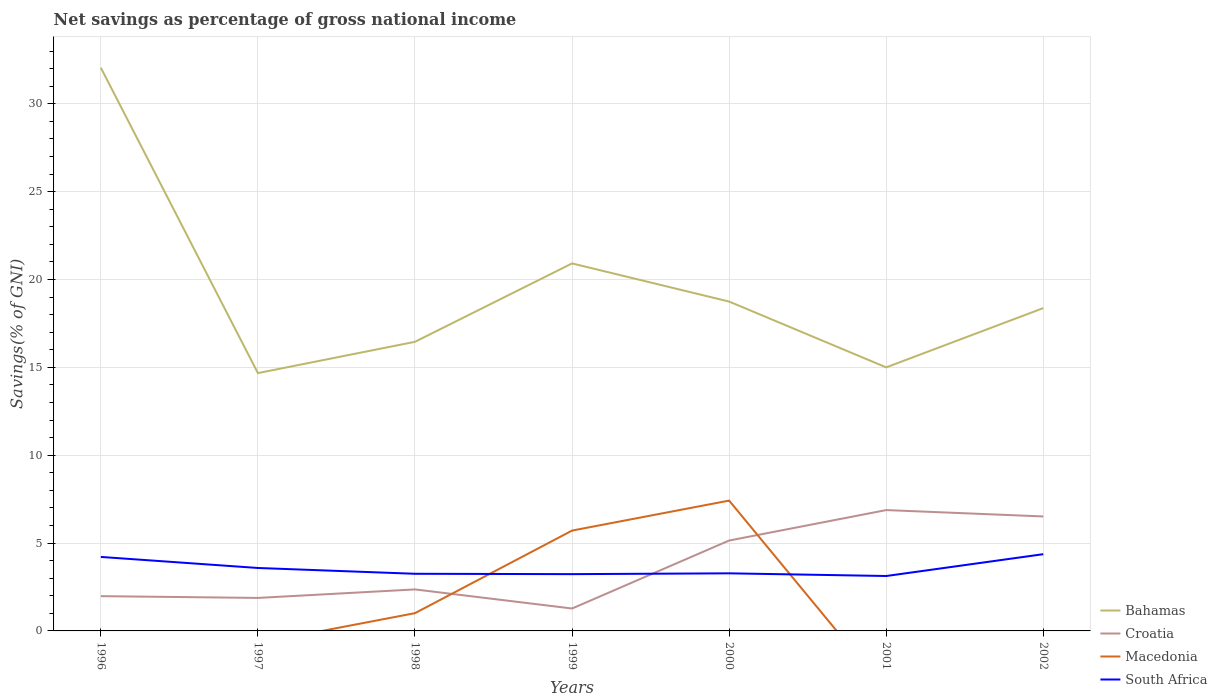Is the number of lines equal to the number of legend labels?
Keep it short and to the point. No. Across all years, what is the maximum total savings in Bahamas?
Give a very brief answer. 14.67. What is the total total savings in South Africa in the graph?
Ensure brevity in your answer.  0.02. What is the difference between the highest and the second highest total savings in Macedonia?
Your answer should be very brief. 7.42. What is the difference between the highest and the lowest total savings in Croatia?
Provide a short and direct response. 3. How are the legend labels stacked?
Your answer should be very brief. Vertical. What is the title of the graph?
Your answer should be very brief. Net savings as percentage of gross national income. What is the label or title of the X-axis?
Give a very brief answer. Years. What is the label or title of the Y-axis?
Your response must be concise. Savings(% of GNI). What is the Savings(% of GNI) in Bahamas in 1996?
Give a very brief answer. 32.05. What is the Savings(% of GNI) in Croatia in 1996?
Your response must be concise. 1.98. What is the Savings(% of GNI) of South Africa in 1996?
Your answer should be very brief. 4.21. What is the Savings(% of GNI) of Bahamas in 1997?
Make the answer very short. 14.67. What is the Savings(% of GNI) of Croatia in 1997?
Your response must be concise. 1.88. What is the Savings(% of GNI) in South Africa in 1997?
Your answer should be compact. 3.58. What is the Savings(% of GNI) in Bahamas in 1998?
Your answer should be compact. 16.45. What is the Savings(% of GNI) of Croatia in 1998?
Your response must be concise. 2.36. What is the Savings(% of GNI) in Macedonia in 1998?
Provide a succinct answer. 1.01. What is the Savings(% of GNI) of South Africa in 1998?
Provide a short and direct response. 3.25. What is the Savings(% of GNI) in Bahamas in 1999?
Your answer should be very brief. 20.91. What is the Savings(% of GNI) in Croatia in 1999?
Your answer should be very brief. 1.28. What is the Savings(% of GNI) of Macedonia in 1999?
Provide a succinct answer. 5.71. What is the Savings(% of GNI) of South Africa in 1999?
Provide a succinct answer. 3.23. What is the Savings(% of GNI) of Bahamas in 2000?
Your response must be concise. 18.74. What is the Savings(% of GNI) in Croatia in 2000?
Your response must be concise. 5.14. What is the Savings(% of GNI) of Macedonia in 2000?
Ensure brevity in your answer.  7.42. What is the Savings(% of GNI) of South Africa in 2000?
Your response must be concise. 3.28. What is the Savings(% of GNI) in Bahamas in 2001?
Your answer should be very brief. 15. What is the Savings(% of GNI) of Croatia in 2001?
Your answer should be very brief. 6.88. What is the Savings(% of GNI) in South Africa in 2001?
Your answer should be very brief. 3.13. What is the Savings(% of GNI) of Bahamas in 2002?
Your answer should be compact. 18.37. What is the Savings(% of GNI) of Croatia in 2002?
Provide a short and direct response. 6.51. What is the Savings(% of GNI) in Macedonia in 2002?
Your answer should be very brief. 0. What is the Savings(% of GNI) in South Africa in 2002?
Offer a very short reply. 4.37. Across all years, what is the maximum Savings(% of GNI) of Bahamas?
Make the answer very short. 32.05. Across all years, what is the maximum Savings(% of GNI) in Croatia?
Provide a short and direct response. 6.88. Across all years, what is the maximum Savings(% of GNI) in Macedonia?
Provide a short and direct response. 7.42. Across all years, what is the maximum Savings(% of GNI) of South Africa?
Provide a short and direct response. 4.37. Across all years, what is the minimum Savings(% of GNI) of Bahamas?
Offer a very short reply. 14.67. Across all years, what is the minimum Savings(% of GNI) in Croatia?
Your response must be concise. 1.28. Across all years, what is the minimum Savings(% of GNI) of Macedonia?
Provide a short and direct response. 0. Across all years, what is the minimum Savings(% of GNI) of South Africa?
Provide a succinct answer. 3.13. What is the total Savings(% of GNI) of Bahamas in the graph?
Your answer should be compact. 136.19. What is the total Savings(% of GNI) of Croatia in the graph?
Keep it short and to the point. 26.03. What is the total Savings(% of GNI) of Macedonia in the graph?
Offer a terse response. 14.14. What is the total Savings(% of GNI) in South Africa in the graph?
Ensure brevity in your answer.  25.05. What is the difference between the Savings(% of GNI) in Bahamas in 1996 and that in 1997?
Give a very brief answer. 17.38. What is the difference between the Savings(% of GNI) of Croatia in 1996 and that in 1997?
Offer a very short reply. 0.1. What is the difference between the Savings(% of GNI) of South Africa in 1996 and that in 1997?
Provide a succinct answer. 0.63. What is the difference between the Savings(% of GNI) in Bahamas in 1996 and that in 1998?
Keep it short and to the point. 15.6. What is the difference between the Savings(% of GNI) of Croatia in 1996 and that in 1998?
Provide a short and direct response. -0.38. What is the difference between the Savings(% of GNI) in South Africa in 1996 and that in 1998?
Keep it short and to the point. 0.96. What is the difference between the Savings(% of GNI) of Bahamas in 1996 and that in 1999?
Make the answer very short. 11.14. What is the difference between the Savings(% of GNI) in Croatia in 1996 and that in 1999?
Offer a terse response. 0.7. What is the difference between the Savings(% of GNI) of South Africa in 1996 and that in 1999?
Offer a terse response. 0.98. What is the difference between the Savings(% of GNI) in Bahamas in 1996 and that in 2000?
Keep it short and to the point. 13.31. What is the difference between the Savings(% of GNI) in Croatia in 1996 and that in 2000?
Ensure brevity in your answer.  -3.17. What is the difference between the Savings(% of GNI) in South Africa in 1996 and that in 2000?
Your answer should be compact. 0.93. What is the difference between the Savings(% of GNI) in Bahamas in 1996 and that in 2001?
Offer a terse response. 17.05. What is the difference between the Savings(% of GNI) of Croatia in 1996 and that in 2001?
Your answer should be compact. -4.9. What is the difference between the Savings(% of GNI) of South Africa in 1996 and that in 2001?
Your answer should be compact. 1.09. What is the difference between the Savings(% of GNI) of Bahamas in 1996 and that in 2002?
Your answer should be very brief. 13.68. What is the difference between the Savings(% of GNI) of Croatia in 1996 and that in 2002?
Your response must be concise. -4.54. What is the difference between the Savings(% of GNI) in South Africa in 1996 and that in 2002?
Offer a very short reply. -0.16. What is the difference between the Savings(% of GNI) of Bahamas in 1997 and that in 1998?
Keep it short and to the point. -1.78. What is the difference between the Savings(% of GNI) of Croatia in 1997 and that in 1998?
Offer a terse response. -0.48. What is the difference between the Savings(% of GNI) in South Africa in 1997 and that in 1998?
Ensure brevity in your answer.  0.33. What is the difference between the Savings(% of GNI) of Bahamas in 1997 and that in 1999?
Make the answer very short. -6.24. What is the difference between the Savings(% of GNI) in Croatia in 1997 and that in 1999?
Your answer should be compact. 0.6. What is the difference between the Savings(% of GNI) of South Africa in 1997 and that in 1999?
Provide a succinct answer. 0.35. What is the difference between the Savings(% of GNI) of Bahamas in 1997 and that in 2000?
Make the answer very short. -4.07. What is the difference between the Savings(% of GNI) of Croatia in 1997 and that in 2000?
Your answer should be compact. -3.27. What is the difference between the Savings(% of GNI) in South Africa in 1997 and that in 2000?
Give a very brief answer. 0.3. What is the difference between the Savings(% of GNI) of Bahamas in 1997 and that in 2001?
Give a very brief answer. -0.33. What is the difference between the Savings(% of GNI) in Croatia in 1997 and that in 2001?
Your answer should be very brief. -5. What is the difference between the Savings(% of GNI) of South Africa in 1997 and that in 2001?
Your answer should be very brief. 0.46. What is the difference between the Savings(% of GNI) of Bahamas in 1997 and that in 2002?
Offer a terse response. -3.7. What is the difference between the Savings(% of GNI) in Croatia in 1997 and that in 2002?
Make the answer very short. -4.64. What is the difference between the Savings(% of GNI) of South Africa in 1997 and that in 2002?
Your response must be concise. -0.78. What is the difference between the Savings(% of GNI) in Bahamas in 1998 and that in 1999?
Give a very brief answer. -4.46. What is the difference between the Savings(% of GNI) in Croatia in 1998 and that in 1999?
Offer a very short reply. 1.09. What is the difference between the Savings(% of GNI) of Macedonia in 1998 and that in 1999?
Your answer should be very brief. -4.7. What is the difference between the Savings(% of GNI) of South Africa in 1998 and that in 1999?
Provide a short and direct response. 0.02. What is the difference between the Savings(% of GNI) in Bahamas in 1998 and that in 2000?
Give a very brief answer. -2.29. What is the difference between the Savings(% of GNI) of Croatia in 1998 and that in 2000?
Your answer should be very brief. -2.78. What is the difference between the Savings(% of GNI) in Macedonia in 1998 and that in 2000?
Make the answer very short. -6.41. What is the difference between the Savings(% of GNI) in South Africa in 1998 and that in 2000?
Make the answer very short. -0.03. What is the difference between the Savings(% of GNI) in Bahamas in 1998 and that in 2001?
Offer a terse response. 1.45. What is the difference between the Savings(% of GNI) in Croatia in 1998 and that in 2001?
Your answer should be compact. -4.52. What is the difference between the Savings(% of GNI) in South Africa in 1998 and that in 2001?
Ensure brevity in your answer.  0.13. What is the difference between the Savings(% of GNI) in Bahamas in 1998 and that in 2002?
Offer a very short reply. -1.92. What is the difference between the Savings(% of GNI) in Croatia in 1998 and that in 2002?
Offer a terse response. -4.15. What is the difference between the Savings(% of GNI) in South Africa in 1998 and that in 2002?
Provide a short and direct response. -1.11. What is the difference between the Savings(% of GNI) in Bahamas in 1999 and that in 2000?
Offer a terse response. 2.17. What is the difference between the Savings(% of GNI) in Croatia in 1999 and that in 2000?
Provide a succinct answer. -3.87. What is the difference between the Savings(% of GNI) in Macedonia in 1999 and that in 2000?
Provide a succinct answer. -1.71. What is the difference between the Savings(% of GNI) of South Africa in 1999 and that in 2000?
Provide a short and direct response. -0.05. What is the difference between the Savings(% of GNI) of Bahamas in 1999 and that in 2001?
Your answer should be very brief. 5.92. What is the difference between the Savings(% of GNI) in Croatia in 1999 and that in 2001?
Offer a very short reply. -5.6. What is the difference between the Savings(% of GNI) of South Africa in 1999 and that in 2001?
Provide a short and direct response. 0.11. What is the difference between the Savings(% of GNI) in Bahamas in 1999 and that in 2002?
Give a very brief answer. 2.54. What is the difference between the Savings(% of GNI) in Croatia in 1999 and that in 2002?
Your answer should be compact. -5.24. What is the difference between the Savings(% of GNI) in South Africa in 1999 and that in 2002?
Keep it short and to the point. -1.14. What is the difference between the Savings(% of GNI) in Bahamas in 2000 and that in 2001?
Your answer should be very brief. 3.74. What is the difference between the Savings(% of GNI) of Croatia in 2000 and that in 2001?
Ensure brevity in your answer.  -1.73. What is the difference between the Savings(% of GNI) of South Africa in 2000 and that in 2001?
Your answer should be compact. 0.15. What is the difference between the Savings(% of GNI) in Bahamas in 2000 and that in 2002?
Make the answer very short. 0.37. What is the difference between the Savings(% of GNI) in Croatia in 2000 and that in 2002?
Your answer should be compact. -1.37. What is the difference between the Savings(% of GNI) of South Africa in 2000 and that in 2002?
Offer a terse response. -1.09. What is the difference between the Savings(% of GNI) of Bahamas in 2001 and that in 2002?
Keep it short and to the point. -3.37. What is the difference between the Savings(% of GNI) in Croatia in 2001 and that in 2002?
Your response must be concise. 0.36. What is the difference between the Savings(% of GNI) of South Africa in 2001 and that in 2002?
Offer a very short reply. -1.24. What is the difference between the Savings(% of GNI) in Bahamas in 1996 and the Savings(% of GNI) in Croatia in 1997?
Keep it short and to the point. 30.17. What is the difference between the Savings(% of GNI) in Bahamas in 1996 and the Savings(% of GNI) in South Africa in 1997?
Make the answer very short. 28.47. What is the difference between the Savings(% of GNI) in Croatia in 1996 and the Savings(% of GNI) in South Africa in 1997?
Your response must be concise. -1.6. What is the difference between the Savings(% of GNI) of Bahamas in 1996 and the Savings(% of GNI) of Croatia in 1998?
Give a very brief answer. 29.69. What is the difference between the Savings(% of GNI) of Bahamas in 1996 and the Savings(% of GNI) of Macedonia in 1998?
Ensure brevity in your answer.  31.04. What is the difference between the Savings(% of GNI) of Bahamas in 1996 and the Savings(% of GNI) of South Africa in 1998?
Give a very brief answer. 28.8. What is the difference between the Savings(% of GNI) of Croatia in 1996 and the Savings(% of GNI) of Macedonia in 1998?
Give a very brief answer. 0.97. What is the difference between the Savings(% of GNI) in Croatia in 1996 and the Savings(% of GNI) in South Africa in 1998?
Your answer should be very brief. -1.27. What is the difference between the Savings(% of GNI) in Bahamas in 1996 and the Savings(% of GNI) in Croatia in 1999?
Provide a short and direct response. 30.77. What is the difference between the Savings(% of GNI) of Bahamas in 1996 and the Savings(% of GNI) of Macedonia in 1999?
Ensure brevity in your answer.  26.34. What is the difference between the Savings(% of GNI) in Bahamas in 1996 and the Savings(% of GNI) in South Africa in 1999?
Your answer should be compact. 28.82. What is the difference between the Savings(% of GNI) of Croatia in 1996 and the Savings(% of GNI) of Macedonia in 1999?
Your answer should be very brief. -3.73. What is the difference between the Savings(% of GNI) of Croatia in 1996 and the Savings(% of GNI) of South Africa in 1999?
Your answer should be compact. -1.25. What is the difference between the Savings(% of GNI) in Bahamas in 1996 and the Savings(% of GNI) in Croatia in 2000?
Ensure brevity in your answer.  26.9. What is the difference between the Savings(% of GNI) in Bahamas in 1996 and the Savings(% of GNI) in Macedonia in 2000?
Your answer should be compact. 24.63. What is the difference between the Savings(% of GNI) of Bahamas in 1996 and the Savings(% of GNI) of South Africa in 2000?
Your answer should be very brief. 28.77. What is the difference between the Savings(% of GNI) in Croatia in 1996 and the Savings(% of GNI) in Macedonia in 2000?
Offer a very short reply. -5.44. What is the difference between the Savings(% of GNI) in Croatia in 1996 and the Savings(% of GNI) in South Africa in 2000?
Offer a terse response. -1.3. What is the difference between the Savings(% of GNI) of Bahamas in 1996 and the Savings(% of GNI) of Croatia in 2001?
Ensure brevity in your answer.  25.17. What is the difference between the Savings(% of GNI) in Bahamas in 1996 and the Savings(% of GNI) in South Africa in 2001?
Your answer should be compact. 28.92. What is the difference between the Savings(% of GNI) in Croatia in 1996 and the Savings(% of GNI) in South Africa in 2001?
Offer a very short reply. -1.15. What is the difference between the Savings(% of GNI) of Bahamas in 1996 and the Savings(% of GNI) of Croatia in 2002?
Your response must be concise. 25.53. What is the difference between the Savings(% of GNI) in Bahamas in 1996 and the Savings(% of GNI) in South Africa in 2002?
Your answer should be very brief. 27.68. What is the difference between the Savings(% of GNI) of Croatia in 1996 and the Savings(% of GNI) of South Africa in 2002?
Make the answer very short. -2.39. What is the difference between the Savings(% of GNI) of Bahamas in 1997 and the Savings(% of GNI) of Croatia in 1998?
Offer a terse response. 12.31. What is the difference between the Savings(% of GNI) in Bahamas in 1997 and the Savings(% of GNI) in Macedonia in 1998?
Provide a succinct answer. 13.66. What is the difference between the Savings(% of GNI) in Bahamas in 1997 and the Savings(% of GNI) in South Africa in 1998?
Provide a succinct answer. 11.42. What is the difference between the Savings(% of GNI) of Croatia in 1997 and the Savings(% of GNI) of Macedonia in 1998?
Ensure brevity in your answer.  0.87. What is the difference between the Savings(% of GNI) in Croatia in 1997 and the Savings(% of GNI) in South Africa in 1998?
Give a very brief answer. -1.37. What is the difference between the Savings(% of GNI) in Bahamas in 1997 and the Savings(% of GNI) in Croatia in 1999?
Provide a succinct answer. 13.4. What is the difference between the Savings(% of GNI) in Bahamas in 1997 and the Savings(% of GNI) in Macedonia in 1999?
Your answer should be compact. 8.96. What is the difference between the Savings(% of GNI) in Bahamas in 1997 and the Savings(% of GNI) in South Africa in 1999?
Your answer should be compact. 11.44. What is the difference between the Savings(% of GNI) of Croatia in 1997 and the Savings(% of GNI) of Macedonia in 1999?
Offer a terse response. -3.83. What is the difference between the Savings(% of GNI) in Croatia in 1997 and the Savings(% of GNI) in South Africa in 1999?
Make the answer very short. -1.35. What is the difference between the Savings(% of GNI) of Bahamas in 1997 and the Savings(% of GNI) of Croatia in 2000?
Give a very brief answer. 9.53. What is the difference between the Savings(% of GNI) in Bahamas in 1997 and the Savings(% of GNI) in Macedonia in 2000?
Provide a short and direct response. 7.25. What is the difference between the Savings(% of GNI) of Bahamas in 1997 and the Savings(% of GNI) of South Africa in 2000?
Provide a short and direct response. 11.39. What is the difference between the Savings(% of GNI) of Croatia in 1997 and the Savings(% of GNI) of Macedonia in 2000?
Give a very brief answer. -5.54. What is the difference between the Savings(% of GNI) of Croatia in 1997 and the Savings(% of GNI) of South Africa in 2000?
Your response must be concise. -1.4. What is the difference between the Savings(% of GNI) in Bahamas in 1997 and the Savings(% of GNI) in Croatia in 2001?
Offer a very short reply. 7.79. What is the difference between the Savings(% of GNI) in Bahamas in 1997 and the Savings(% of GNI) in South Africa in 2001?
Offer a terse response. 11.55. What is the difference between the Savings(% of GNI) of Croatia in 1997 and the Savings(% of GNI) of South Africa in 2001?
Make the answer very short. -1.25. What is the difference between the Savings(% of GNI) of Bahamas in 1997 and the Savings(% of GNI) of Croatia in 2002?
Keep it short and to the point. 8.16. What is the difference between the Savings(% of GNI) of Bahamas in 1997 and the Savings(% of GNI) of South Africa in 2002?
Your answer should be very brief. 10.3. What is the difference between the Savings(% of GNI) in Croatia in 1997 and the Savings(% of GNI) in South Africa in 2002?
Provide a succinct answer. -2.49. What is the difference between the Savings(% of GNI) of Bahamas in 1998 and the Savings(% of GNI) of Croatia in 1999?
Give a very brief answer. 15.18. What is the difference between the Savings(% of GNI) of Bahamas in 1998 and the Savings(% of GNI) of Macedonia in 1999?
Provide a short and direct response. 10.74. What is the difference between the Savings(% of GNI) in Bahamas in 1998 and the Savings(% of GNI) in South Africa in 1999?
Your answer should be very brief. 13.22. What is the difference between the Savings(% of GNI) in Croatia in 1998 and the Savings(% of GNI) in Macedonia in 1999?
Ensure brevity in your answer.  -3.35. What is the difference between the Savings(% of GNI) of Croatia in 1998 and the Savings(% of GNI) of South Africa in 1999?
Offer a very short reply. -0.87. What is the difference between the Savings(% of GNI) of Macedonia in 1998 and the Savings(% of GNI) of South Africa in 1999?
Keep it short and to the point. -2.22. What is the difference between the Savings(% of GNI) in Bahamas in 1998 and the Savings(% of GNI) in Croatia in 2000?
Keep it short and to the point. 11.31. What is the difference between the Savings(% of GNI) in Bahamas in 1998 and the Savings(% of GNI) in Macedonia in 2000?
Provide a succinct answer. 9.04. What is the difference between the Savings(% of GNI) in Bahamas in 1998 and the Savings(% of GNI) in South Africa in 2000?
Ensure brevity in your answer.  13.17. What is the difference between the Savings(% of GNI) of Croatia in 1998 and the Savings(% of GNI) of Macedonia in 2000?
Offer a very short reply. -5.05. What is the difference between the Savings(% of GNI) of Croatia in 1998 and the Savings(% of GNI) of South Africa in 2000?
Provide a short and direct response. -0.92. What is the difference between the Savings(% of GNI) in Macedonia in 1998 and the Savings(% of GNI) in South Africa in 2000?
Offer a terse response. -2.27. What is the difference between the Savings(% of GNI) in Bahamas in 1998 and the Savings(% of GNI) in Croatia in 2001?
Ensure brevity in your answer.  9.58. What is the difference between the Savings(% of GNI) of Bahamas in 1998 and the Savings(% of GNI) of South Africa in 2001?
Offer a very short reply. 13.33. What is the difference between the Savings(% of GNI) in Croatia in 1998 and the Savings(% of GNI) in South Africa in 2001?
Your response must be concise. -0.76. What is the difference between the Savings(% of GNI) in Macedonia in 1998 and the Savings(% of GNI) in South Africa in 2001?
Offer a terse response. -2.11. What is the difference between the Savings(% of GNI) of Bahamas in 1998 and the Savings(% of GNI) of Croatia in 2002?
Provide a succinct answer. 9.94. What is the difference between the Savings(% of GNI) of Bahamas in 1998 and the Savings(% of GNI) of South Africa in 2002?
Ensure brevity in your answer.  12.09. What is the difference between the Savings(% of GNI) in Croatia in 1998 and the Savings(% of GNI) in South Africa in 2002?
Your answer should be compact. -2. What is the difference between the Savings(% of GNI) in Macedonia in 1998 and the Savings(% of GNI) in South Africa in 2002?
Keep it short and to the point. -3.36. What is the difference between the Savings(% of GNI) of Bahamas in 1999 and the Savings(% of GNI) of Croatia in 2000?
Your response must be concise. 15.77. What is the difference between the Savings(% of GNI) of Bahamas in 1999 and the Savings(% of GNI) of Macedonia in 2000?
Keep it short and to the point. 13.5. What is the difference between the Savings(% of GNI) of Bahamas in 1999 and the Savings(% of GNI) of South Africa in 2000?
Make the answer very short. 17.63. What is the difference between the Savings(% of GNI) of Croatia in 1999 and the Savings(% of GNI) of Macedonia in 2000?
Offer a terse response. -6.14. What is the difference between the Savings(% of GNI) in Croatia in 1999 and the Savings(% of GNI) in South Africa in 2000?
Give a very brief answer. -2. What is the difference between the Savings(% of GNI) in Macedonia in 1999 and the Savings(% of GNI) in South Africa in 2000?
Your answer should be compact. 2.43. What is the difference between the Savings(% of GNI) in Bahamas in 1999 and the Savings(% of GNI) in Croatia in 2001?
Offer a terse response. 14.04. What is the difference between the Savings(% of GNI) of Bahamas in 1999 and the Savings(% of GNI) of South Africa in 2001?
Your answer should be very brief. 17.79. What is the difference between the Savings(% of GNI) of Croatia in 1999 and the Savings(% of GNI) of South Africa in 2001?
Keep it short and to the point. -1.85. What is the difference between the Savings(% of GNI) in Macedonia in 1999 and the Savings(% of GNI) in South Africa in 2001?
Ensure brevity in your answer.  2.58. What is the difference between the Savings(% of GNI) of Bahamas in 1999 and the Savings(% of GNI) of Croatia in 2002?
Give a very brief answer. 14.4. What is the difference between the Savings(% of GNI) of Bahamas in 1999 and the Savings(% of GNI) of South Africa in 2002?
Make the answer very short. 16.55. What is the difference between the Savings(% of GNI) in Croatia in 1999 and the Savings(% of GNI) in South Africa in 2002?
Give a very brief answer. -3.09. What is the difference between the Savings(% of GNI) of Macedonia in 1999 and the Savings(% of GNI) of South Africa in 2002?
Give a very brief answer. 1.34. What is the difference between the Savings(% of GNI) in Bahamas in 2000 and the Savings(% of GNI) in Croatia in 2001?
Your answer should be very brief. 11.87. What is the difference between the Savings(% of GNI) of Bahamas in 2000 and the Savings(% of GNI) of South Africa in 2001?
Give a very brief answer. 15.62. What is the difference between the Savings(% of GNI) of Croatia in 2000 and the Savings(% of GNI) of South Africa in 2001?
Provide a short and direct response. 2.02. What is the difference between the Savings(% of GNI) in Macedonia in 2000 and the Savings(% of GNI) in South Africa in 2001?
Offer a very short reply. 4.29. What is the difference between the Savings(% of GNI) of Bahamas in 2000 and the Savings(% of GNI) of Croatia in 2002?
Keep it short and to the point. 12.23. What is the difference between the Savings(% of GNI) in Bahamas in 2000 and the Savings(% of GNI) in South Africa in 2002?
Provide a succinct answer. 14.38. What is the difference between the Savings(% of GNI) of Croatia in 2000 and the Savings(% of GNI) of South Africa in 2002?
Give a very brief answer. 0.78. What is the difference between the Savings(% of GNI) in Macedonia in 2000 and the Savings(% of GNI) in South Africa in 2002?
Keep it short and to the point. 3.05. What is the difference between the Savings(% of GNI) of Bahamas in 2001 and the Savings(% of GNI) of Croatia in 2002?
Your answer should be compact. 8.48. What is the difference between the Savings(% of GNI) of Bahamas in 2001 and the Savings(% of GNI) of South Africa in 2002?
Make the answer very short. 10.63. What is the difference between the Savings(% of GNI) of Croatia in 2001 and the Savings(% of GNI) of South Africa in 2002?
Provide a succinct answer. 2.51. What is the average Savings(% of GNI) in Bahamas per year?
Provide a short and direct response. 19.46. What is the average Savings(% of GNI) of Croatia per year?
Provide a succinct answer. 3.72. What is the average Savings(% of GNI) in Macedonia per year?
Provide a short and direct response. 2.02. What is the average Savings(% of GNI) of South Africa per year?
Make the answer very short. 3.58. In the year 1996, what is the difference between the Savings(% of GNI) of Bahamas and Savings(% of GNI) of Croatia?
Your answer should be very brief. 30.07. In the year 1996, what is the difference between the Savings(% of GNI) in Bahamas and Savings(% of GNI) in South Africa?
Offer a very short reply. 27.84. In the year 1996, what is the difference between the Savings(% of GNI) of Croatia and Savings(% of GNI) of South Africa?
Your answer should be compact. -2.23. In the year 1997, what is the difference between the Savings(% of GNI) of Bahamas and Savings(% of GNI) of Croatia?
Provide a short and direct response. 12.79. In the year 1997, what is the difference between the Savings(% of GNI) in Bahamas and Savings(% of GNI) in South Africa?
Ensure brevity in your answer.  11.09. In the year 1997, what is the difference between the Savings(% of GNI) of Croatia and Savings(% of GNI) of South Africa?
Your response must be concise. -1.7. In the year 1998, what is the difference between the Savings(% of GNI) of Bahamas and Savings(% of GNI) of Croatia?
Your answer should be compact. 14.09. In the year 1998, what is the difference between the Savings(% of GNI) of Bahamas and Savings(% of GNI) of Macedonia?
Your answer should be compact. 15.44. In the year 1998, what is the difference between the Savings(% of GNI) in Bahamas and Savings(% of GNI) in South Africa?
Ensure brevity in your answer.  13.2. In the year 1998, what is the difference between the Savings(% of GNI) of Croatia and Savings(% of GNI) of Macedonia?
Make the answer very short. 1.35. In the year 1998, what is the difference between the Savings(% of GNI) of Croatia and Savings(% of GNI) of South Africa?
Your answer should be compact. -0.89. In the year 1998, what is the difference between the Savings(% of GNI) of Macedonia and Savings(% of GNI) of South Africa?
Your answer should be very brief. -2.24. In the year 1999, what is the difference between the Savings(% of GNI) of Bahamas and Savings(% of GNI) of Croatia?
Keep it short and to the point. 19.64. In the year 1999, what is the difference between the Savings(% of GNI) in Bahamas and Savings(% of GNI) in Macedonia?
Your response must be concise. 15.2. In the year 1999, what is the difference between the Savings(% of GNI) of Bahamas and Savings(% of GNI) of South Africa?
Provide a short and direct response. 17.68. In the year 1999, what is the difference between the Savings(% of GNI) in Croatia and Savings(% of GNI) in Macedonia?
Provide a succinct answer. -4.43. In the year 1999, what is the difference between the Savings(% of GNI) in Croatia and Savings(% of GNI) in South Africa?
Your response must be concise. -1.96. In the year 1999, what is the difference between the Savings(% of GNI) of Macedonia and Savings(% of GNI) of South Africa?
Give a very brief answer. 2.48. In the year 2000, what is the difference between the Savings(% of GNI) of Bahamas and Savings(% of GNI) of Croatia?
Offer a terse response. 13.6. In the year 2000, what is the difference between the Savings(% of GNI) in Bahamas and Savings(% of GNI) in Macedonia?
Your answer should be very brief. 11.33. In the year 2000, what is the difference between the Savings(% of GNI) in Bahamas and Savings(% of GNI) in South Africa?
Keep it short and to the point. 15.46. In the year 2000, what is the difference between the Savings(% of GNI) in Croatia and Savings(% of GNI) in Macedonia?
Your response must be concise. -2.27. In the year 2000, what is the difference between the Savings(% of GNI) in Croatia and Savings(% of GNI) in South Africa?
Provide a succinct answer. 1.87. In the year 2000, what is the difference between the Savings(% of GNI) of Macedonia and Savings(% of GNI) of South Africa?
Ensure brevity in your answer.  4.14. In the year 2001, what is the difference between the Savings(% of GNI) of Bahamas and Savings(% of GNI) of Croatia?
Your answer should be very brief. 8.12. In the year 2001, what is the difference between the Savings(% of GNI) in Bahamas and Savings(% of GNI) in South Africa?
Ensure brevity in your answer.  11.87. In the year 2001, what is the difference between the Savings(% of GNI) in Croatia and Savings(% of GNI) in South Africa?
Your answer should be compact. 3.75. In the year 2002, what is the difference between the Savings(% of GNI) of Bahamas and Savings(% of GNI) of Croatia?
Your answer should be very brief. 11.86. In the year 2002, what is the difference between the Savings(% of GNI) of Bahamas and Savings(% of GNI) of South Africa?
Your response must be concise. 14. In the year 2002, what is the difference between the Savings(% of GNI) of Croatia and Savings(% of GNI) of South Africa?
Provide a succinct answer. 2.15. What is the ratio of the Savings(% of GNI) of Bahamas in 1996 to that in 1997?
Provide a short and direct response. 2.18. What is the ratio of the Savings(% of GNI) in Croatia in 1996 to that in 1997?
Make the answer very short. 1.05. What is the ratio of the Savings(% of GNI) of South Africa in 1996 to that in 1997?
Offer a very short reply. 1.18. What is the ratio of the Savings(% of GNI) in Bahamas in 1996 to that in 1998?
Offer a terse response. 1.95. What is the ratio of the Savings(% of GNI) in Croatia in 1996 to that in 1998?
Offer a very short reply. 0.84. What is the ratio of the Savings(% of GNI) of South Africa in 1996 to that in 1998?
Your answer should be compact. 1.29. What is the ratio of the Savings(% of GNI) of Bahamas in 1996 to that in 1999?
Give a very brief answer. 1.53. What is the ratio of the Savings(% of GNI) of Croatia in 1996 to that in 1999?
Keep it short and to the point. 1.55. What is the ratio of the Savings(% of GNI) of South Africa in 1996 to that in 1999?
Your answer should be very brief. 1.3. What is the ratio of the Savings(% of GNI) in Bahamas in 1996 to that in 2000?
Offer a very short reply. 1.71. What is the ratio of the Savings(% of GNI) of Croatia in 1996 to that in 2000?
Your response must be concise. 0.38. What is the ratio of the Savings(% of GNI) in South Africa in 1996 to that in 2000?
Provide a short and direct response. 1.28. What is the ratio of the Savings(% of GNI) of Bahamas in 1996 to that in 2001?
Offer a terse response. 2.14. What is the ratio of the Savings(% of GNI) of Croatia in 1996 to that in 2001?
Ensure brevity in your answer.  0.29. What is the ratio of the Savings(% of GNI) in South Africa in 1996 to that in 2001?
Your response must be concise. 1.35. What is the ratio of the Savings(% of GNI) in Bahamas in 1996 to that in 2002?
Give a very brief answer. 1.74. What is the ratio of the Savings(% of GNI) of Croatia in 1996 to that in 2002?
Offer a terse response. 0.3. What is the ratio of the Savings(% of GNI) of South Africa in 1996 to that in 2002?
Offer a terse response. 0.96. What is the ratio of the Savings(% of GNI) of Bahamas in 1997 to that in 1998?
Ensure brevity in your answer.  0.89. What is the ratio of the Savings(% of GNI) of Croatia in 1997 to that in 1998?
Provide a succinct answer. 0.8. What is the ratio of the Savings(% of GNI) of South Africa in 1997 to that in 1998?
Your response must be concise. 1.1. What is the ratio of the Savings(% of GNI) of Bahamas in 1997 to that in 1999?
Your answer should be compact. 0.7. What is the ratio of the Savings(% of GNI) in Croatia in 1997 to that in 1999?
Keep it short and to the point. 1.47. What is the ratio of the Savings(% of GNI) of South Africa in 1997 to that in 1999?
Your answer should be very brief. 1.11. What is the ratio of the Savings(% of GNI) of Bahamas in 1997 to that in 2000?
Provide a short and direct response. 0.78. What is the ratio of the Savings(% of GNI) of Croatia in 1997 to that in 2000?
Make the answer very short. 0.36. What is the ratio of the Savings(% of GNI) of South Africa in 1997 to that in 2000?
Your response must be concise. 1.09. What is the ratio of the Savings(% of GNI) in Bahamas in 1997 to that in 2001?
Offer a very short reply. 0.98. What is the ratio of the Savings(% of GNI) of Croatia in 1997 to that in 2001?
Provide a succinct answer. 0.27. What is the ratio of the Savings(% of GNI) in South Africa in 1997 to that in 2001?
Your answer should be compact. 1.15. What is the ratio of the Savings(% of GNI) in Bahamas in 1997 to that in 2002?
Provide a succinct answer. 0.8. What is the ratio of the Savings(% of GNI) in Croatia in 1997 to that in 2002?
Provide a succinct answer. 0.29. What is the ratio of the Savings(% of GNI) of South Africa in 1997 to that in 2002?
Offer a very short reply. 0.82. What is the ratio of the Savings(% of GNI) of Bahamas in 1998 to that in 1999?
Your answer should be very brief. 0.79. What is the ratio of the Savings(% of GNI) in Croatia in 1998 to that in 1999?
Offer a very short reply. 1.85. What is the ratio of the Savings(% of GNI) of Macedonia in 1998 to that in 1999?
Give a very brief answer. 0.18. What is the ratio of the Savings(% of GNI) of South Africa in 1998 to that in 1999?
Offer a very short reply. 1.01. What is the ratio of the Savings(% of GNI) of Bahamas in 1998 to that in 2000?
Ensure brevity in your answer.  0.88. What is the ratio of the Savings(% of GNI) of Croatia in 1998 to that in 2000?
Provide a short and direct response. 0.46. What is the ratio of the Savings(% of GNI) in Macedonia in 1998 to that in 2000?
Your response must be concise. 0.14. What is the ratio of the Savings(% of GNI) of South Africa in 1998 to that in 2000?
Offer a very short reply. 0.99. What is the ratio of the Savings(% of GNI) of Bahamas in 1998 to that in 2001?
Keep it short and to the point. 1.1. What is the ratio of the Savings(% of GNI) of Croatia in 1998 to that in 2001?
Your answer should be compact. 0.34. What is the ratio of the Savings(% of GNI) of South Africa in 1998 to that in 2001?
Your answer should be very brief. 1.04. What is the ratio of the Savings(% of GNI) in Bahamas in 1998 to that in 2002?
Provide a succinct answer. 0.9. What is the ratio of the Savings(% of GNI) of Croatia in 1998 to that in 2002?
Offer a terse response. 0.36. What is the ratio of the Savings(% of GNI) in South Africa in 1998 to that in 2002?
Ensure brevity in your answer.  0.74. What is the ratio of the Savings(% of GNI) of Bahamas in 1999 to that in 2000?
Your answer should be compact. 1.12. What is the ratio of the Savings(% of GNI) in Croatia in 1999 to that in 2000?
Keep it short and to the point. 0.25. What is the ratio of the Savings(% of GNI) in Macedonia in 1999 to that in 2000?
Keep it short and to the point. 0.77. What is the ratio of the Savings(% of GNI) of South Africa in 1999 to that in 2000?
Your answer should be compact. 0.99. What is the ratio of the Savings(% of GNI) of Bahamas in 1999 to that in 2001?
Offer a very short reply. 1.39. What is the ratio of the Savings(% of GNI) of Croatia in 1999 to that in 2001?
Give a very brief answer. 0.19. What is the ratio of the Savings(% of GNI) in South Africa in 1999 to that in 2001?
Keep it short and to the point. 1.03. What is the ratio of the Savings(% of GNI) in Bahamas in 1999 to that in 2002?
Your answer should be compact. 1.14. What is the ratio of the Savings(% of GNI) in Croatia in 1999 to that in 2002?
Give a very brief answer. 0.2. What is the ratio of the Savings(% of GNI) of South Africa in 1999 to that in 2002?
Ensure brevity in your answer.  0.74. What is the ratio of the Savings(% of GNI) in Bahamas in 2000 to that in 2001?
Provide a succinct answer. 1.25. What is the ratio of the Savings(% of GNI) of Croatia in 2000 to that in 2001?
Your answer should be compact. 0.75. What is the ratio of the Savings(% of GNI) of South Africa in 2000 to that in 2001?
Keep it short and to the point. 1.05. What is the ratio of the Savings(% of GNI) in Bahamas in 2000 to that in 2002?
Give a very brief answer. 1.02. What is the ratio of the Savings(% of GNI) in Croatia in 2000 to that in 2002?
Your answer should be compact. 0.79. What is the ratio of the Savings(% of GNI) of South Africa in 2000 to that in 2002?
Provide a succinct answer. 0.75. What is the ratio of the Savings(% of GNI) in Bahamas in 2001 to that in 2002?
Make the answer very short. 0.82. What is the ratio of the Savings(% of GNI) in Croatia in 2001 to that in 2002?
Keep it short and to the point. 1.06. What is the ratio of the Savings(% of GNI) in South Africa in 2001 to that in 2002?
Offer a very short reply. 0.72. What is the difference between the highest and the second highest Savings(% of GNI) in Bahamas?
Make the answer very short. 11.14. What is the difference between the highest and the second highest Savings(% of GNI) of Croatia?
Offer a terse response. 0.36. What is the difference between the highest and the second highest Savings(% of GNI) in Macedonia?
Offer a very short reply. 1.71. What is the difference between the highest and the second highest Savings(% of GNI) of South Africa?
Provide a succinct answer. 0.16. What is the difference between the highest and the lowest Savings(% of GNI) in Bahamas?
Your answer should be very brief. 17.38. What is the difference between the highest and the lowest Savings(% of GNI) in Croatia?
Your answer should be compact. 5.6. What is the difference between the highest and the lowest Savings(% of GNI) of Macedonia?
Provide a short and direct response. 7.42. What is the difference between the highest and the lowest Savings(% of GNI) of South Africa?
Your answer should be compact. 1.24. 